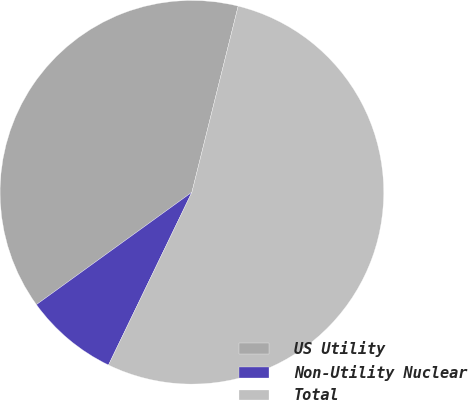<chart> <loc_0><loc_0><loc_500><loc_500><pie_chart><fcel>US Utility<fcel>Non-Utility Nuclear<fcel>Total<nl><fcel>38.84%<fcel>7.88%<fcel>53.28%<nl></chart> 